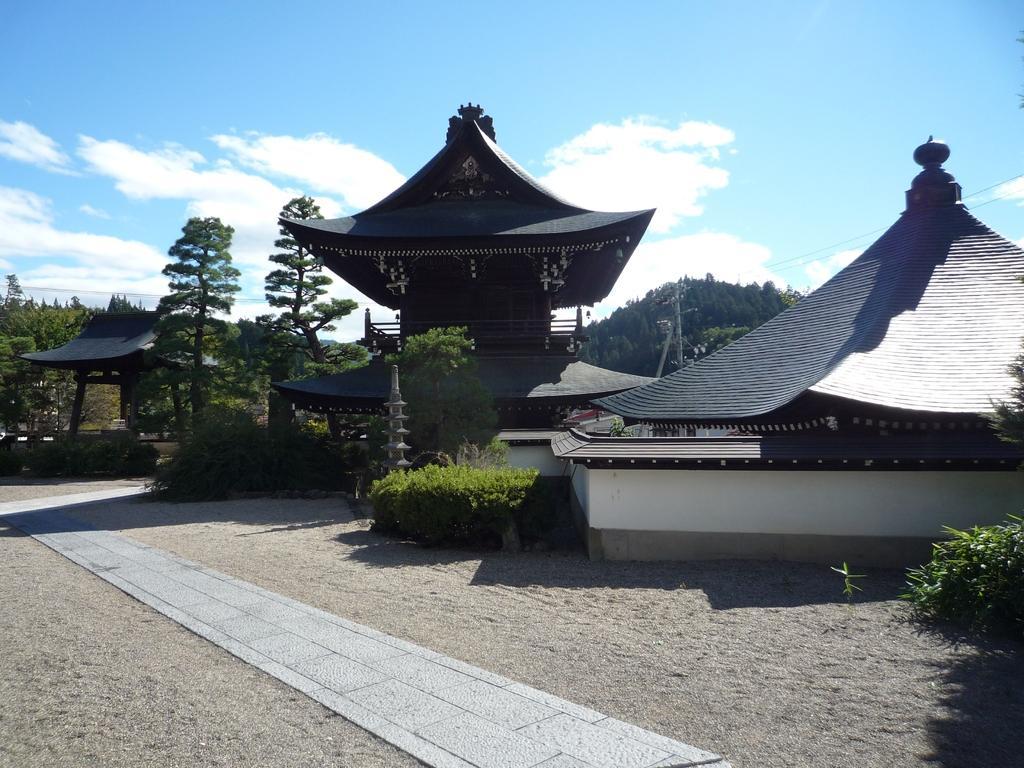Could you give a brief overview of what you see in this image? In this picture we can see some Buddha temples with roof tiles. Behind there are some trees. In the front bottom side there is a walking area. On the top there is a sky and clouds. 